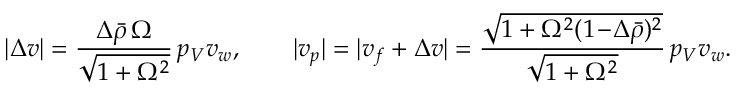Convert formula to latex. <formula><loc_0><loc_0><loc_500><loc_500>| \Delta v | = \frac { \Delta \bar { \rho } \, \Omega } { \sqrt { 1 + \Omega ^ { 2 } } } \, p _ { V } v _ { w } , \quad | v _ { p } | = | v _ { f } + \Delta v | = \frac { \sqrt { 1 + \Omega ^ { 2 } ( 1 \, - \, \Delta \bar { \rho } ) ^ { 2 } } } { \sqrt { 1 + \Omega ^ { 2 } } } \, p _ { V } v _ { w } .</formula> 